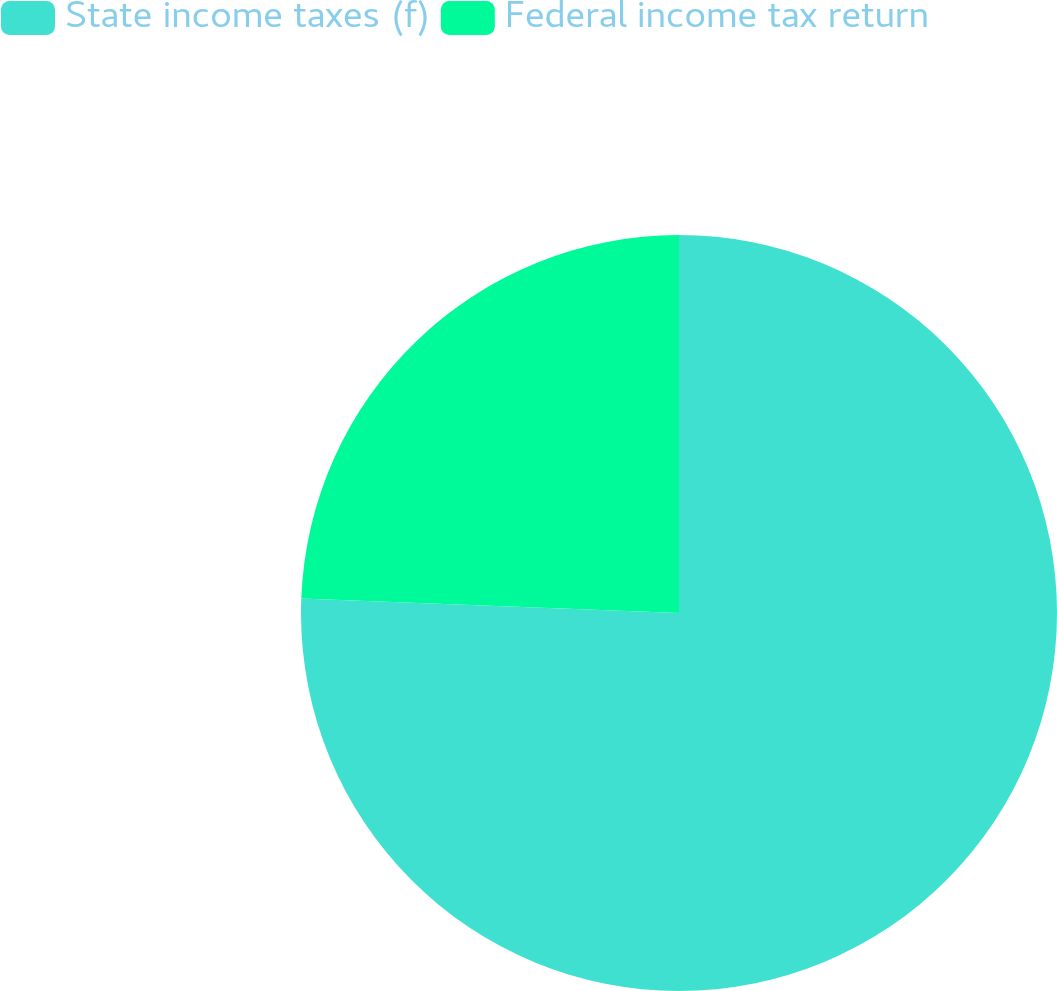Convert chart. <chart><loc_0><loc_0><loc_500><loc_500><pie_chart><fcel>State income taxes (f)<fcel>Federal income tax return<nl><fcel>75.61%<fcel>24.39%<nl></chart> 